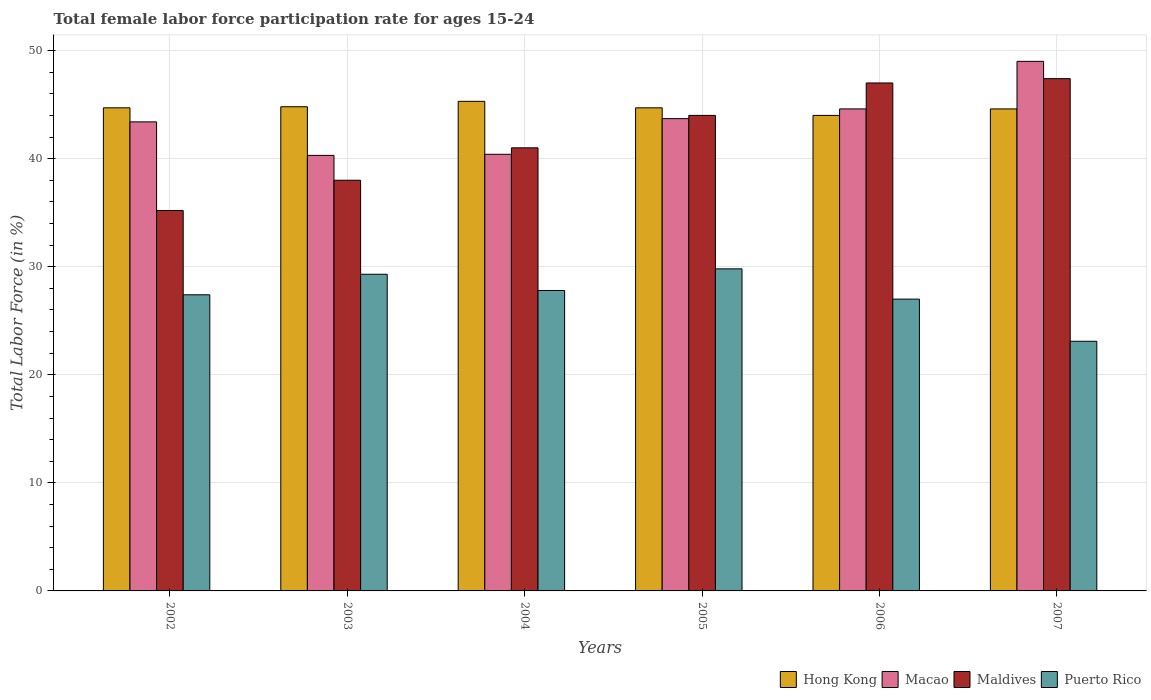How many different coloured bars are there?
Your response must be concise. 4. What is the label of the 5th group of bars from the left?
Provide a short and direct response. 2006. What is the female labor force participation rate in Hong Kong in 2004?
Offer a very short reply. 45.3. Across all years, what is the minimum female labor force participation rate in Puerto Rico?
Offer a terse response. 23.1. In which year was the female labor force participation rate in Maldives maximum?
Ensure brevity in your answer.  2007. In which year was the female labor force participation rate in Macao minimum?
Make the answer very short. 2003. What is the total female labor force participation rate in Macao in the graph?
Your answer should be very brief. 261.4. What is the difference between the female labor force participation rate in Puerto Rico in 2003 and the female labor force participation rate in Maldives in 2005?
Make the answer very short. -14.7. What is the average female labor force participation rate in Hong Kong per year?
Provide a short and direct response. 44.68. In the year 2004, what is the difference between the female labor force participation rate in Puerto Rico and female labor force participation rate in Macao?
Your response must be concise. -12.6. What is the ratio of the female labor force participation rate in Macao in 2004 to that in 2007?
Your answer should be compact. 0.82. What is the difference between the highest and the second highest female labor force participation rate in Macao?
Your answer should be very brief. 4.4. What is the difference between the highest and the lowest female labor force participation rate in Maldives?
Provide a short and direct response. 12.2. In how many years, is the female labor force participation rate in Maldives greater than the average female labor force participation rate in Maldives taken over all years?
Ensure brevity in your answer.  3. Is the sum of the female labor force participation rate in Maldives in 2003 and 2005 greater than the maximum female labor force participation rate in Hong Kong across all years?
Offer a very short reply. Yes. Is it the case that in every year, the sum of the female labor force participation rate in Puerto Rico and female labor force participation rate in Macao is greater than the sum of female labor force participation rate in Maldives and female labor force participation rate in Hong Kong?
Provide a short and direct response. No. What does the 2nd bar from the left in 2004 represents?
Your answer should be compact. Macao. What does the 3rd bar from the right in 2004 represents?
Make the answer very short. Macao. Is it the case that in every year, the sum of the female labor force participation rate in Maldives and female labor force participation rate in Hong Kong is greater than the female labor force participation rate in Puerto Rico?
Give a very brief answer. Yes. Are all the bars in the graph horizontal?
Your answer should be very brief. No. How many years are there in the graph?
Provide a short and direct response. 6. Are the values on the major ticks of Y-axis written in scientific E-notation?
Provide a short and direct response. No. How many legend labels are there?
Give a very brief answer. 4. How are the legend labels stacked?
Your answer should be very brief. Horizontal. What is the title of the graph?
Provide a succinct answer. Total female labor force participation rate for ages 15-24. What is the label or title of the X-axis?
Your response must be concise. Years. What is the label or title of the Y-axis?
Your answer should be very brief. Total Labor Force (in %). What is the Total Labor Force (in %) of Hong Kong in 2002?
Offer a terse response. 44.7. What is the Total Labor Force (in %) in Macao in 2002?
Keep it short and to the point. 43.4. What is the Total Labor Force (in %) of Maldives in 2002?
Keep it short and to the point. 35.2. What is the Total Labor Force (in %) in Puerto Rico in 2002?
Give a very brief answer. 27.4. What is the Total Labor Force (in %) in Hong Kong in 2003?
Provide a short and direct response. 44.8. What is the Total Labor Force (in %) in Macao in 2003?
Provide a short and direct response. 40.3. What is the Total Labor Force (in %) in Maldives in 2003?
Offer a terse response. 38. What is the Total Labor Force (in %) of Puerto Rico in 2003?
Provide a succinct answer. 29.3. What is the Total Labor Force (in %) of Hong Kong in 2004?
Your answer should be compact. 45.3. What is the Total Labor Force (in %) of Macao in 2004?
Your answer should be very brief. 40.4. What is the Total Labor Force (in %) of Puerto Rico in 2004?
Provide a short and direct response. 27.8. What is the Total Labor Force (in %) of Hong Kong in 2005?
Make the answer very short. 44.7. What is the Total Labor Force (in %) in Macao in 2005?
Offer a terse response. 43.7. What is the Total Labor Force (in %) of Maldives in 2005?
Provide a short and direct response. 44. What is the Total Labor Force (in %) of Puerto Rico in 2005?
Your answer should be very brief. 29.8. What is the Total Labor Force (in %) of Hong Kong in 2006?
Offer a terse response. 44. What is the Total Labor Force (in %) in Macao in 2006?
Provide a short and direct response. 44.6. What is the Total Labor Force (in %) of Puerto Rico in 2006?
Ensure brevity in your answer.  27. What is the Total Labor Force (in %) in Hong Kong in 2007?
Ensure brevity in your answer.  44.6. What is the Total Labor Force (in %) of Macao in 2007?
Make the answer very short. 49. What is the Total Labor Force (in %) in Maldives in 2007?
Ensure brevity in your answer.  47.4. What is the Total Labor Force (in %) in Puerto Rico in 2007?
Provide a succinct answer. 23.1. Across all years, what is the maximum Total Labor Force (in %) of Hong Kong?
Make the answer very short. 45.3. Across all years, what is the maximum Total Labor Force (in %) of Maldives?
Ensure brevity in your answer.  47.4. Across all years, what is the maximum Total Labor Force (in %) of Puerto Rico?
Provide a short and direct response. 29.8. Across all years, what is the minimum Total Labor Force (in %) of Macao?
Offer a terse response. 40.3. Across all years, what is the minimum Total Labor Force (in %) in Maldives?
Offer a terse response. 35.2. Across all years, what is the minimum Total Labor Force (in %) of Puerto Rico?
Provide a succinct answer. 23.1. What is the total Total Labor Force (in %) in Hong Kong in the graph?
Offer a very short reply. 268.1. What is the total Total Labor Force (in %) in Macao in the graph?
Your answer should be very brief. 261.4. What is the total Total Labor Force (in %) of Maldives in the graph?
Give a very brief answer. 252.6. What is the total Total Labor Force (in %) of Puerto Rico in the graph?
Provide a succinct answer. 164.4. What is the difference between the Total Labor Force (in %) in Hong Kong in 2002 and that in 2003?
Your response must be concise. -0.1. What is the difference between the Total Labor Force (in %) of Macao in 2002 and that in 2003?
Give a very brief answer. 3.1. What is the difference between the Total Labor Force (in %) of Maldives in 2002 and that in 2003?
Offer a terse response. -2.8. What is the difference between the Total Labor Force (in %) in Hong Kong in 2002 and that in 2004?
Your answer should be very brief. -0.6. What is the difference between the Total Labor Force (in %) of Puerto Rico in 2002 and that in 2004?
Give a very brief answer. -0.4. What is the difference between the Total Labor Force (in %) of Hong Kong in 2002 and that in 2005?
Your response must be concise. 0. What is the difference between the Total Labor Force (in %) in Maldives in 2002 and that in 2006?
Ensure brevity in your answer.  -11.8. What is the difference between the Total Labor Force (in %) in Puerto Rico in 2002 and that in 2006?
Ensure brevity in your answer.  0.4. What is the difference between the Total Labor Force (in %) of Hong Kong in 2002 and that in 2007?
Offer a terse response. 0.1. What is the difference between the Total Labor Force (in %) of Macao in 2002 and that in 2007?
Provide a succinct answer. -5.6. What is the difference between the Total Labor Force (in %) of Hong Kong in 2003 and that in 2004?
Give a very brief answer. -0.5. What is the difference between the Total Labor Force (in %) of Puerto Rico in 2003 and that in 2004?
Keep it short and to the point. 1.5. What is the difference between the Total Labor Force (in %) in Macao in 2003 and that in 2007?
Provide a short and direct response. -8.7. What is the difference between the Total Labor Force (in %) of Maldives in 2003 and that in 2007?
Provide a short and direct response. -9.4. What is the difference between the Total Labor Force (in %) in Hong Kong in 2004 and that in 2006?
Offer a terse response. 1.3. What is the difference between the Total Labor Force (in %) in Macao in 2004 and that in 2006?
Keep it short and to the point. -4.2. What is the difference between the Total Labor Force (in %) of Maldives in 2004 and that in 2006?
Make the answer very short. -6. What is the difference between the Total Labor Force (in %) in Puerto Rico in 2004 and that in 2007?
Make the answer very short. 4.7. What is the difference between the Total Labor Force (in %) in Hong Kong in 2005 and that in 2006?
Provide a succinct answer. 0.7. What is the difference between the Total Labor Force (in %) in Macao in 2005 and that in 2006?
Make the answer very short. -0.9. What is the difference between the Total Labor Force (in %) in Maldives in 2005 and that in 2006?
Ensure brevity in your answer.  -3. What is the difference between the Total Labor Force (in %) of Hong Kong in 2005 and that in 2007?
Keep it short and to the point. 0.1. What is the difference between the Total Labor Force (in %) in Macao in 2005 and that in 2007?
Offer a very short reply. -5.3. What is the difference between the Total Labor Force (in %) of Maldives in 2005 and that in 2007?
Ensure brevity in your answer.  -3.4. What is the difference between the Total Labor Force (in %) of Macao in 2006 and that in 2007?
Give a very brief answer. -4.4. What is the difference between the Total Labor Force (in %) in Puerto Rico in 2006 and that in 2007?
Provide a succinct answer. 3.9. What is the difference between the Total Labor Force (in %) of Hong Kong in 2002 and the Total Labor Force (in %) of Maldives in 2003?
Provide a short and direct response. 6.7. What is the difference between the Total Labor Force (in %) of Macao in 2002 and the Total Labor Force (in %) of Maldives in 2003?
Make the answer very short. 5.4. What is the difference between the Total Labor Force (in %) of Maldives in 2002 and the Total Labor Force (in %) of Puerto Rico in 2003?
Ensure brevity in your answer.  5.9. What is the difference between the Total Labor Force (in %) of Hong Kong in 2002 and the Total Labor Force (in %) of Puerto Rico in 2004?
Provide a short and direct response. 16.9. What is the difference between the Total Labor Force (in %) of Macao in 2002 and the Total Labor Force (in %) of Puerto Rico in 2004?
Your answer should be compact. 15.6. What is the difference between the Total Labor Force (in %) of Hong Kong in 2002 and the Total Labor Force (in %) of Maldives in 2005?
Your answer should be compact. 0.7. What is the difference between the Total Labor Force (in %) of Hong Kong in 2002 and the Total Labor Force (in %) of Puerto Rico in 2005?
Make the answer very short. 14.9. What is the difference between the Total Labor Force (in %) in Macao in 2002 and the Total Labor Force (in %) in Puerto Rico in 2005?
Ensure brevity in your answer.  13.6. What is the difference between the Total Labor Force (in %) in Maldives in 2002 and the Total Labor Force (in %) in Puerto Rico in 2005?
Ensure brevity in your answer.  5.4. What is the difference between the Total Labor Force (in %) in Hong Kong in 2002 and the Total Labor Force (in %) in Macao in 2006?
Your response must be concise. 0.1. What is the difference between the Total Labor Force (in %) in Hong Kong in 2002 and the Total Labor Force (in %) in Maldives in 2006?
Your answer should be compact. -2.3. What is the difference between the Total Labor Force (in %) of Macao in 2002 and the Total Labor Force (in %) of Maldives in 2006?
Provide a succinct answer. -3.6. What is the difference between the Total Labor Force (in %) in Maldives in 2002 and the Total Labor Force (in %) in Puerto Rico in 2006?
Give a very brief answer. 8.2. What is the difference between the Total Labor Force (in %) of Hong Kong in 2002 and the Total Labor Force (in %) of Macao in 2007?
Keep it short and to the point. -4.3. What is the difference between the Total Labor Force (in %) in Hong Kong in 2002 and the Total Labor Force (in %) in Puerto Rico in 2007?
Keep it short and to the point. 21.6. What is the difference between the Total Labor Force (in %) of Macao in 2002 and the Total Labor Force (in %) of Puerto Rico in 2007?
Your response must be concise. 20.3. What is the difference between the Total Labor Force (in %) of Macao in 2003 and the Total Labor Force (in %) of Puerto Rico in 2004?
Your answer should be very brief. 12.5. What is the difference between the Total Labor Force (in %) of Maldives in 2003 and the Total Labor Force (in %) of Puerto Rico in 2004?
Make the answer very short. 10.2. What is the difference between the Total Labor Force (in %) of Hong Kong in 2003 and the Total Labor Force (in %) of Maldives in 2005?
Keep it short and to the point. 0.8. What is the difference between the Total Labor Force (in %) in Macao in 2003 and the Total Labor Force (in %) in Maldives in 2005?
Your answer should be very brief. -3.7. What is the difference between the Total Labor Force (in %) in Macao in 2003 and the Total Labor Force (in %) in Puerto Rico in 2005?
Your answer should be very brief. 10.5. What is the difference between the Total Labor Force (in %) in Hong Kong in 2003 and the Total Labor Force (in %) in Macao in 2006?
Keep it short and to the point. 0.2. What is the difference between the Total Labor Force (in %) of Hong Kong in 2003 and the Total Labor Force (in %) of Maldives in 2006?
Provide a succinct answer. -2.2. What is the difference between the Total Labor Force (in %) in Macao in 2003 and the Total Labor Force (in %) in Maldives in 2006?
Your response must be concise. -6.7. What is the difference between the Total Labor Force (in %) in Macao in 2003 and the Total Labor Force (in %) in Puerto Rico in 2006?
Give a very brief answer. 13.3. What is the difference between the Total Labor Force (in %) of Maldives in 2003 and the Total Labor Force (in %) of Puerto Rico in 2006?
Make the answer very short. 11. What is the difference between the Total Labor Force (in %) of Hong Kong in 2003 and the Total Labor Force (in %) of Puerto Rico in 2007?
Provide a short and direct response. 21.7. What is the difference between the Total Labor Force (in %) in Macao in 2003 and the Total Labor Force (in %) in Puerto Rico in 2007?
Offer a very short reply. 17.2. What is the difference between the Total Labor Force (in %) in Hong Kong in 2004 and the Total Labor Force (in %) in Macao in 2005?
Provide a succinct answer. 1.6. What is the difference between the Total Labor Force (in %) of Hong Kong in 2004 and the Total Labor Force (in %) of Maldives in 2005?
Offer a very short reply. 1.3. What is the difference between the Total Labor Force (in %) in Hong Kong in 2004 and the Total Labor Force (in %) in Maldives in 2006?
Give a very brief answer. -1.7. What is the difference between the Total Labor Force (in %) in Hong Kong in 2004 and the Total Labor Force (in %) in Puerto Rico in 2006?
Your answer should be very brief. 18.3. What is the difference between the Total Labor Force (in %) in Macao in 2004 and the Total Labor Force (in %) in Puerto Rico in 2006?
Your response must be concise. 13.4. What is the difference between the Total Labor Force (in %) in Maldives in 2004 and the Total Labor Force (in %) in Puerto Rico in 2006?
Give a very brief answer. 14. What is the difference between the Total Labor Force (in %) in Hong Kong in 2004 and the Total Labor Force (in %) in Macao in 2007?
Ensure brevity in your answer.  -3.7. What is the difference between the Total Labor Force (in %) in Maldives in 2004 and the Total Labor Force (in %) in Puerto Rico in 2007?
Provide a succinct answer. 17.9. What is the difference between the Total Labor Force (in %) in Hong Kong in 2005 and the Total Labor Force (in %) in Macao in 2006?
Offer a very short reply. 0.1. What is the difference between the Total Labor Force (in %) in Hong Kong in 2005 and the Total Labor Force (in %) in Maldives in 2006?
Keep it short and to the point. -2.3. What is the difference between the Total Labor Force (in %) of Hong Kong in 2005 and the Total Labor Force (in %) of Puerto Rico in 2006?
Offer a terse response. 17.7. What is the difference between the Total Labor Force (in %) of Macao in 2005 and the Total Labor Force (in %) of Puerto Rico in 2006?
Your response must be concise. 16.7. What is the difference between the Total Labor Force (in %) of Maldives in 2005 and the Total Labor Force (in %) of Puerto Rico in 2006?
Offer a very short reply. 17. What is the difference between the Total Labor Force (in %) in Hong Kong in 2005 and the Total Labor Force (in %) in Puerto Rico in 2007?
Provide a short and direct response. 21.6. What is the difference between the Total Labor Force (in %) in Macao in 2005 and the Total Labor Force (in %) in Maldives in 2007?
Your answer should be very brief. -3.7. What is the difference between the Total Labor Force (in %) in Macao in 2005 and the Total Labor Force (in %) in Puerto Rico in 2007?
Make the answer very short. 20.6. What is the difference between the Total Labor Force (in %) in Maldives in 2005 and the Total Labor Force (in %) in Puerto Rico in 2007?
Ensure brevity in your answer.  20.9. What is the difference between the Total Labor Force (in %) of Hong Kong in 2006 and the Total Labor Force (in %) of Maldives in 2007?
Your response must be concise. -3.4. What is the difference between the Total Labor Force (in %) in Hong Kong in 2006 and the Total Labor Force (in %) in Puerto Rico in 2007?
Provide a short and direct response. 20.9. What is the difference between the Total Labor Force (in %) in Maldives in 2006 and the Total Labor Force (in %) in Puerto Rico in 2007?
Your answer should be very brief. 23.9. What is the average Total Labor Force (in %) of Hong Kong per year?
Keep it short and to the point. 44.68. What is the average Total Labor Force (in %) in Macao per year?
Ensure brevity in your answer.  43.57. What is the average Total Labor Force (in %) of Maldives per year?
Keep it short and to the point. 42.1. What is the average Total Labor Force (in %) of Puerto Rico per year?
Provide a short and direct response. 27.4. In the year 2002, what is the difference between the Total Labor Force (in %) in Hong Kong and Total Labor Force (in %) in Macao?
Make the answer very short. 1.3. In the year 2002, what is the difference between the Total Labor Force (in %) in Hong Kong and Total Labor Force (in %) in Maldives?
Offer a terse response. 9.5. In the year 2002, what is the difference between the Total Labor Force (in %) in Hong Kong and Total Labor Force (in %) in Puerto Rico?
Offer a terse response. 17.3. In the year 2002, what is the difference between the Total Labor Force (in %) of Maldives and Total Labor Force (in %) of Puerto Rico?
Your answer should be very brief. 7.8. In the year 2003, what is the difference between the Total Labor Force (in %) in Hong Kong and Total Labor Force (in %) in Macao?
Offer a very short reply. 4.5. In the year 2003, what is the difference between the Total Labor Force (in %) in Hong Kong and Total Labor Force (in %) in Maldives?
Your response must be concise. 6.8. In the year 2003, what is the difference between the Total Labor Force (in %) in Hong Kong and Total Labor Force (in %) in Puerto Rico?
Offer a terse response. 15.5. In the year 2003, what is the difference between the Total Labor Force (in %) in Macao and Total Labor Force (in %) in Maldives?
Provide a succinct answer. 2.3. In the year 2003, what is the difference between the Total Labor Force (in %) in Maldives and Total Labor Force (in %) in Puerto Rico?
Make the answer very short. 8.7. In the year 2004, what is the difference between the Total Labor Force (in %) of Hong Kong and Total Labor Force (in %) of Maldives?
Ensure brevity in your answer.  4.3. In the year 2004, what is the difference between the Total Labor Force (in %) in Hong Kong and Total Labor Force (in %) in Puerto Rico?
Give a very brief answer. 17.5. In the year 2004, what is the difference between the Total Labor Force (in %) of Macao and Total Labor Force (in %) of Maldives?
Your answer should be very brief. -0.6. In the year 2005, what is the difference between the Total Labor Force (in %) in Macao and Total Labor Force (in %) in Maldives?
Keep it short and to the point. -0.3. In the year 2005, what is the difference between the Total Labor Force (in %) of Macao and Total Labor Force (in %) of Puerto Rico?
Your response must be concise. 13.9. In the year 2005, what is the difference between the Total Labor Force (in %) of Maldives and Total Labor Force (in %) of Puerto Rico?
Your answer should be compact. 14.2. In the year 2006, what is the difference between the Total Labor Force (in %) of Hong Kong and Total Labor Force (in %) of Macao?
Give a very brief answer. -0.6. In the year 2006, what is the difference between the Total Labor Force (in %) of Hong Kong and Total Labor Force (in %) of Puerto Rico?
Keep it short and to the point. 17. In the year 2006, what is the difference between the Total Labor Force (in %) in Macao and Total Labor Force (in %) in Maldives?
Ensure brevity in your answer.  -2.4. In the year 2006, what is the difference between the Total Labor Force (in %) in Macao and Total Labor Force (in %) in Puerto Rico?
Your response must be concise. 17.6. In the year 2007, what is the difference between the Total Labor Force (in %) of Hong Kong and Total Labor Force (in %) of Maldives?
Your response must be concise. -2.8. In the year 2007, what is the difference between the Total Labor Force (in %) of Hong Kong and Total Labor Force (in %) of Puerto Rico?
Your answer should be compact. 21.5. In the year 2007, what is the difference between the Total Labor Force (in %) in Macao and Total Labor Force (in %) in Maldives?
Your answer should be compact. 1.6. In the year 2007, what is the difference between the Total Labor Force (in %) of Macao and Total Labor Force (in %) of Puerto Rico?
Ensure brevity in your answer.  25.9. In the year 2007, what is the difference between the Total Labor Force (in %) in Maldives and Total Labor Force (in %) in Puerto Rico?
Provide a short and direct response. 24.3. What is the ratio of the Total Labor Force (in %) of Hong Kong in 2002 to that in 2003?
Provide a short and direct response. 1. What is the ratio of the Total Labor Force (in %) of Maldives in 2002 to that in 2003?
Offer a very short reply. 0.93. What is the ratio of the Total Labor Force (in %) of Puerto Rico in 2002 to that in 2003?
Give a very brief answer. 0.94. What is the ratio of the Total Labor Force (in %) of Hong Kong in 2002 to that in 2004?
Provide a succinct answer. 0.99. What is the ratio of the Total Labor Force (in %) in Macao in 2002 to that in 2004?
Give a very brief answer. 1.07. What is the ratio of the Total Labor Force (in %) of Maldives in 2002 to that in 2004?
Make the answer very short. 0.86. What is the ratio of the Total Labor Force (in %) of Puerto Rico in 2002 to that in 2004?
Your response must be concise. 0.99. What is the ratio of the Total Labor Force (in %) in Macao in 2002 to that in 2005?
Offer a terse response. 0.99. What is the ratio of the Total Labor Force (in %) of Maldives in 2002 to that in 2005?
Keep it short and to the point. 0.8. What is the ratio of the Total Labor Force (in %) of Puerto Rico in 2002 to that in 2005?
Ensure brevity in your answer.  0.92. What is the ratio of the Total Labor Force (in %) in Hong Kong in 2002 to that in 2006?
Your answer should be very brief. 1.02. What is the ratio of the Total Labor Force (in %) of Macao in 2002 to that in 2006?
Your answer should be very brief. 0.97. What is the ratio of the Total Labor Force (in %) of Maldives in 2002 to that in 2006?
Your answer should be very brief. 0.75. What is the ratio of the Total Labor Force (in %) of Puerto Rico in 2002 to that in 2006?
Your answer should be compact. 1.01. What is the ratio of the Total Labor Force (in %) of Hong Kong in 2002 to that in 2007?
Ensure brevity in your answer.  1. What is the ratio of the Total Labor Force (in %) in Macao in 2002 to that in 2007?
Give a very brief answer. 0.89. What is the ratio of the Total Labor Force (in %) in Maldives in 2002 to that in 2007?
Your answer should be very brief. 0.74. What is the ratio of the Total Labor Force (in %) of Puerto Rico in 2002 to that in 2007?
Offer a very short reply. 1.19. What is the ratio of the Total Labor Force (in %) of Hong Kong in 2003 to that in 2004?
Your answer should be compact. 0.99. What is the ratio of the Total Labor Force (in %) in Macao in 2003 to that in 2004?
Your answer should be compact. 1. What is the ratio of the Total Labor Force (in %) in Maldives in 2003 to that in 2004?
Your answer should be very brief. 0.93. What is the ratio of the Total Labor Force (in %) of Puerto Rico in 2003 to that in 2004?
Keep it short and to the point. 1.05. What is the ratio of the Total Labor Force (in %) in Macao in 2003 to that in 2005?
Keep it short and to the point. 0.92. What is the ratio of the Total Labor Force (in %) in Maldives in 2003 to that in 2005?
Offer a very short reply. 0.86. What is the ratio of the Total Labor Force (in %) in Puerto Rico in 2003 to that in 2005?
Offer a very short reply. 0.98. What is the ratio of the Total Labor Force (in %) of Hong Kong in 2003 to that in 2006?
Keep it short and to the point. 1.02. What is the ratio of the Total Labor Force (in %) of Macao in 2003 to that in 2006?
Give a very brief answer. 0.9. What is the ratio of the Total Labor Force (in %) in Maldives in 2003 to that in 2006?
Your response must be concise. 0.81. What is the ratio of the Total Labor Force (in %) of Puerto Rico in 2003 to that in 2006?
Your answer should be compact. 1.09. What is the ratio of the Total Labor Force (in %) in Hong Kong in 2003 to that in 2007?
Provide a short and direct response. 1. What is the ratio of the Total Labor Force (in %) of Macao in 2003 to that in 2007?
Offer a very short reply. 0.82. What is the ratio of the Total Labor Force (in %) of Maldives in 2003 to that in 2007?
Provide a short and direct response. 0.8. What is the ratio of the Total Labor Force (in %) in Puerto Rico in 2003 to that in 2007?
Provide a succinct answer. 1.27. What is the ratio of the Total Labor Force (in %) of Hong Kong in 2004 to that in 2005?
Offer a terse response. 1.01. What is the ratio of the Total Labor Force (in %) in Macao in 2004 to that in 2005?
Provide a short and direct response. 0.92. What is the ratio of the Total Labor Force (in %) of Maldives in 2004 to that in 2005?
Your answer should be compact. 0.93. What is the ratio of the Total Labor Force (in %) of Puerto Rico in 2004 to that in 2005?
Your answer should be compact. 0.93. What is the ratio of the Total Labor Force (in %) in Hong Kong in 2004 to that in 2006?
Ensure brevity in your answer.  1.03. What is the ratio of the Total Labor Force (in %) in Macao in 2004 to that in 2006?
Offer a very short reply. 0.91. What is the ratio of the Total Labor Force (in %) of Maldives in 2004 to that in 2006?
Your answer should be compact. 0.87. What is the ratio of the Total Labor Force (in %) of Puerto Rico in 2004 to that in 2006?
Provide a succinct answer. 1.03. What is the ratio of the Total Labor Force (in %) in Hong Kong in 2004 to that in 2007?
Make the answer very short. 1.02. What is the ratio of the Total Labor Force (in %) in Macao in 2004 to that in 2007?
Ensure brevity in your answer.  0.82. What is the ratio of the Total Labor Force (in %) in Maldives in 2004 to that in 2007?
Your response must be concise. 0.86. What is the ratio of the Total Labor Force (in %) in Puerto Rico in 2004 to that in 2007?
Provide a succinct answer. 1.2. What is the ratio of the Total Labor Force (in %) of Hong Kong in 2005 to that in 2006?
Keep it short and to the point. 1.02. What is the ratio of the Total Labor Force (in %) in Macao in 2005 to that in 2006?
Offer a terse response. 0.98. What is the ratio of the Total Labor Force (in %) of Maldives in 2005 to that in 2006?
Make the answer very short. 0.94. What is the ratio of the Total Labor Force (in %) in Puerto Rico in 2005 to that in 2006?
Make the answer very short. 1.1. What is the ratio of the Total Labor Force (in %) of Hong Kong in 2005 to that in 2007?
Your response must be concise. 1. What is the ratio of the Total Labor Force (in %) of Macao in 2005 to that in 2007?
Keep it short and to the point. 0.89. What is the ratio of the Total Labor Force (in %) of Maldives in 2005 to that in 2007?
Your answer should be compact. 0.93. What is the ratio of the Total Labor Force (in %) of Puerto Rico in 2005 to that in 2007?
Your response must be concise. 1.29. What is the ratio of the Total Labor Force (in %) in Hong Kong in 2006 to that in 2007?
Keep it short and to the point. 0.99. What is the ratio of the Total Labor Force (in %) in Macao in 2006 to that in 2007?
Ensure brevity in your answer.  0.91. What is the ratio of the Total Labor Force (in %) of Puerto Rico in 2006 to that in 2007?
Offer a very short reply. 1.17. What is the difference between the highest and the second highest Total Labor Force (in %) in Macao?
Keep it short and to the point. 4.4. What is the difference between the highest and the second highest Total Labor Force (in %) of Maldives?
Give a very brief answer. 0.4. What is the difference between the highest and the second highest Total Labor Force (in %) of Puerto Rico?
Your response must be concise. 0.5. What is the difference between the highest and the lowest Total Labor Force (in %) in Macao?
Provide a succinct answer. 8.7. What is the difference between the highest and the lowest Total Labor Force (in %) in Puerto Rico?
Provide a succinct answer. 6.7. 